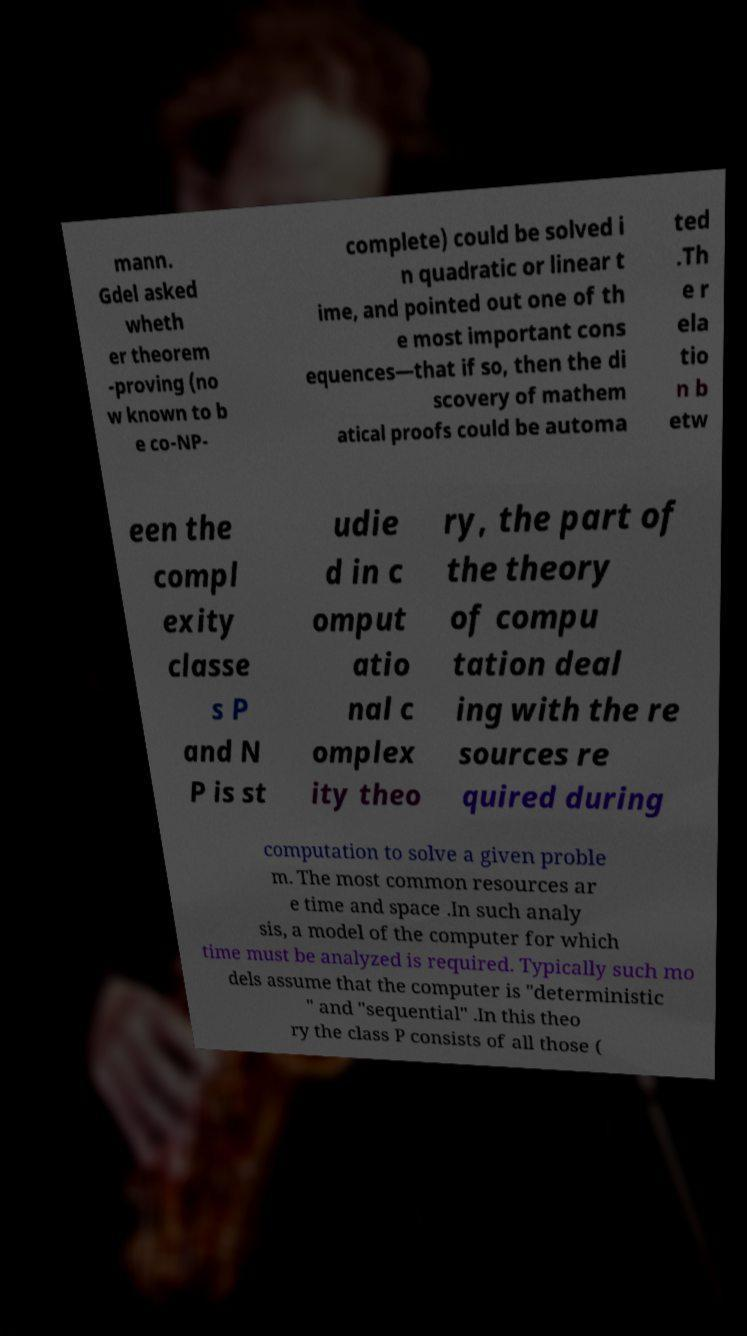What messages or text are displayed in this image? I need them in a readable, typed format. mann. Gdel asked wheth er theorem -proving (no w known to b e co-NP- complete) could be solved i n quadratic or linear t ime, and pointed out one of th e most important cons equences—that if so, then the di scovery of mathem atical proofs could be automa ted .Th e r ela tio n b etw een the compl exity classe s P and N P is st udie d in c omput atio nal c omplex ity theo ry, the part of the theory of compu tation deal ing with the re sources re quired during computation to solve a given proble m. The most common resources ar e time and space .In such analy sis, a model of the computer for which time must be analyzed is required. Typically such mo dels assume that the computer is "deterministic " and "sequential" .In this theo ry the class P consists of all those ( 